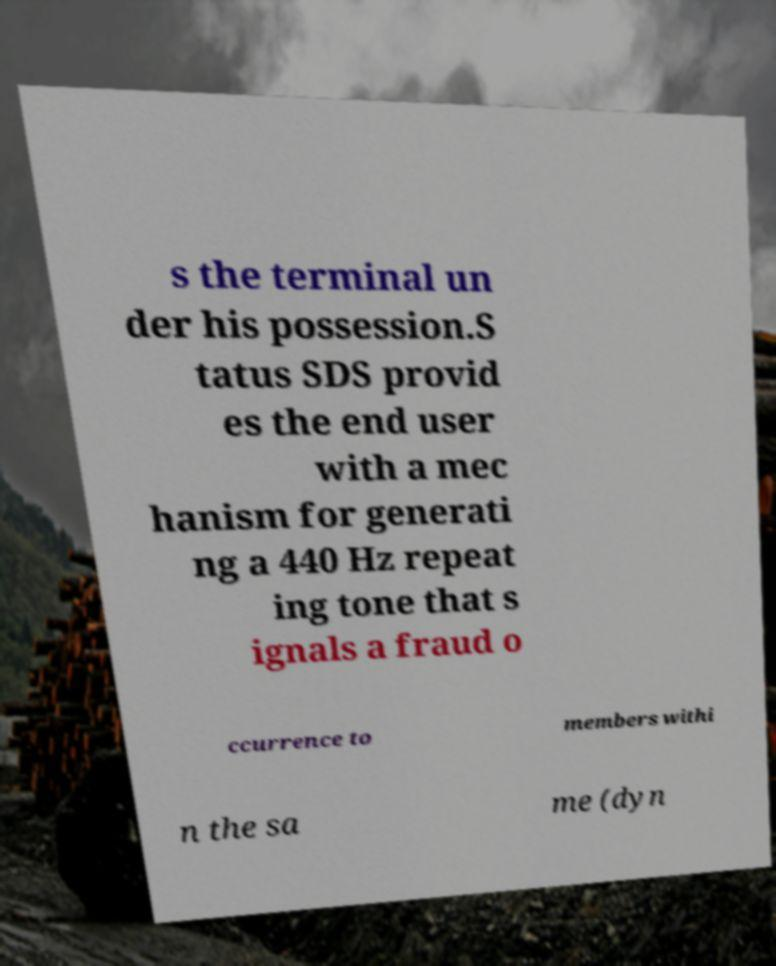For documentation purposes, I need the text within this image transcribed. Could you provide that? s the terminal un der his possession.S tatus SDS provid es the end user with a mec hanism for generati ng a 440 Hz repeat ing tone that s ignals a fraud o ccurrence to members withi n the sa me (dyn 